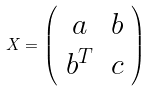Convert formula to latex. <formula><loc_0><loc_0><loc_500><loc_500>X = \left ( \begin{array} { c c } a & b \\ b ^ { T } & c \\ \end{array} \right )</formula> 